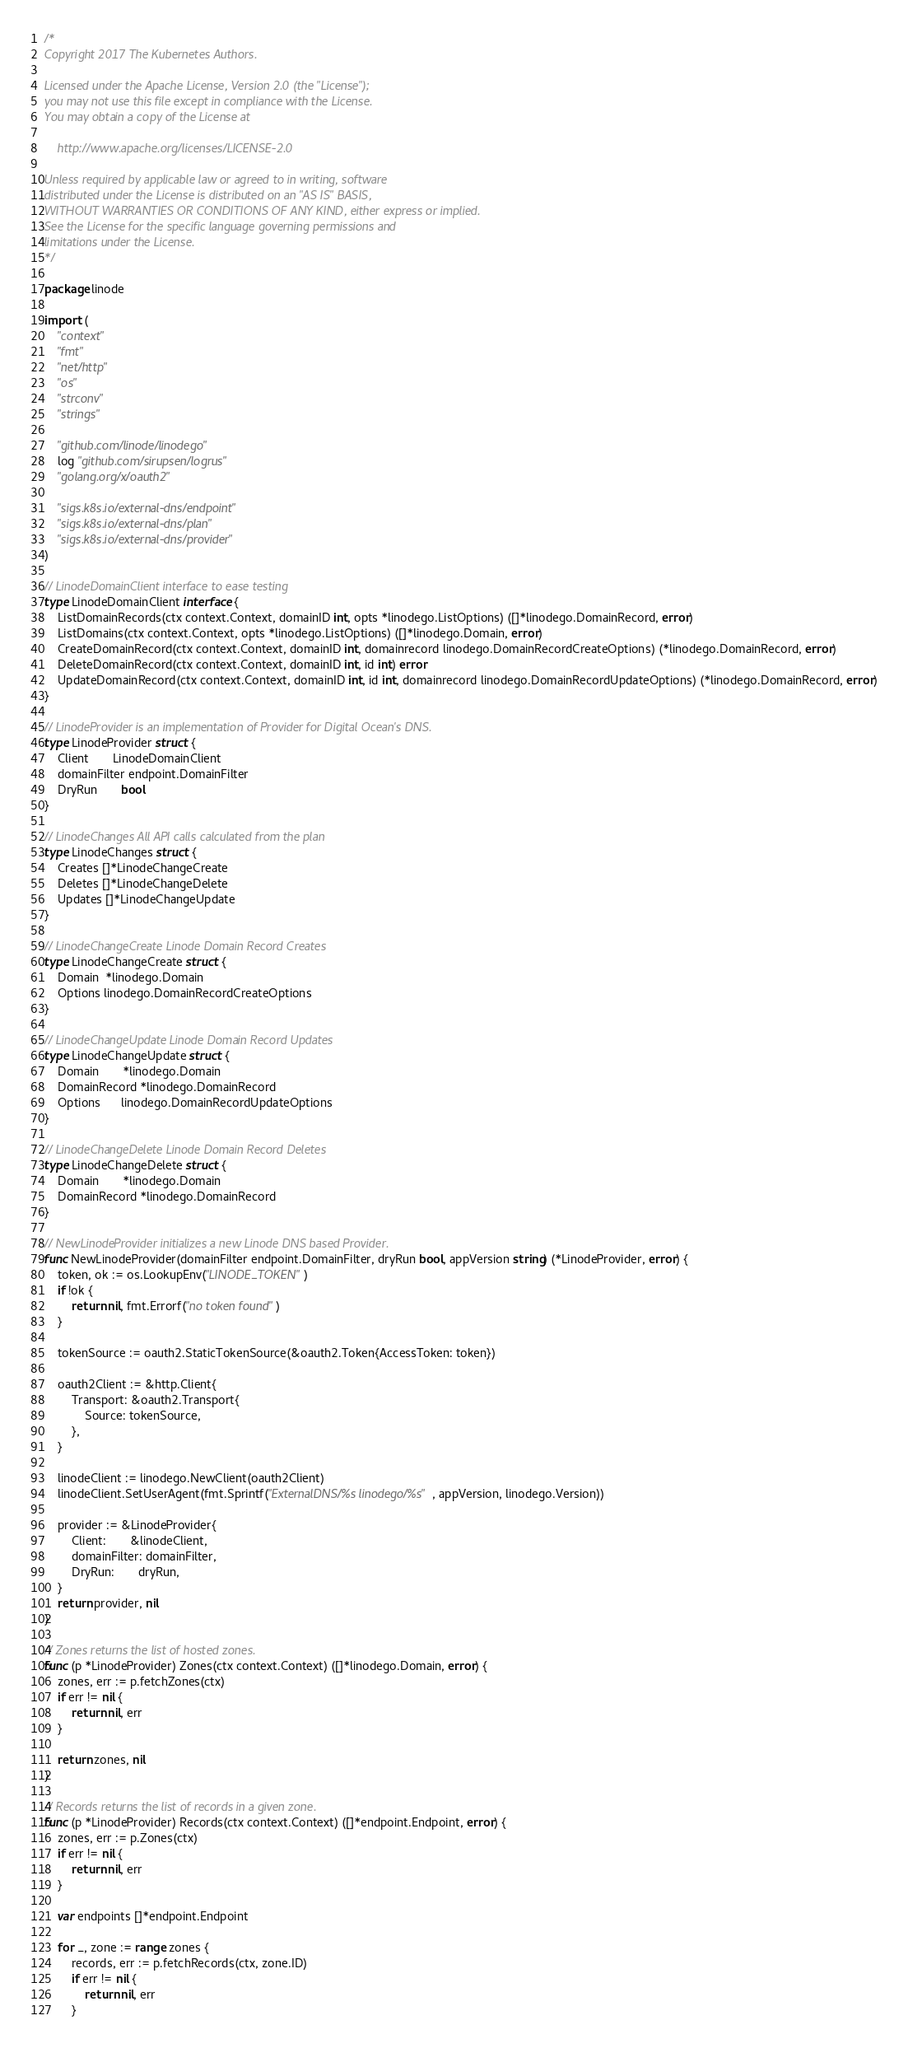Convert code to text. <code><loc_0><loc_0><loc_500><loc_500><_Go_>/*
Copyright 2017 The Kubernetes Authors.

Licensed under the Apache License, Version 2.0 (the "License");
you may not use this file except in compliance with the License.
You may obtain a copy of the License at

    http://www.apache.org/licenses/LICENSE-2.0

Unless required by applicable law or agreed to in writing, software
distributed under the License is distributed on an "AS IS" BASIS,
WITHOUT WARRANTIES OR CONDITIONS OF ANY KIND, either express or implied.
See the License for the specific language governing permissions and
limitations under the License.
*/

package linode

import (
	"context"
	"fmt"
	"net/http"
	"os"
	"strconv"
	"strings"

	"github.com/linode/linodego"
	log "github.com/sirupsen/logrus"
	"golang.org/x/oauth2"

	"sigs.k8s.io/external-dns/endpoint"
	"sigs.k8s.io/external-dns/plan"
	"sigs.k8s.io/external-dns/provider"
)

// LinodeDomainClient interface to ease testing
type LinodeDomainClient interface {
	ListDomainRecords(ctx context.Context, domainID int, opts *linodego.ListOptions) ([]*linodego.DomainRecord, error)
	ListDomains(ctx context.Context, opts *linodego.ListOptions) ([]*linodego.Domain, error)
	CreateDomainRecord(ctx context.Context, domainID int, domainrecord linodego.DomainRecordCreateOptions) (*linodego.DomainRecord, error)
	DeleteDomainRecord(ctx context.Context, domainID int, id int) error
	UpdateDomainRecord(ctx context.Context, domainID int, id int, domainrecord linodego.DomainRecordUpdateOptions) (*linodego.DomainRecord, error)
}

// LinodeProvider is an implementation of Provider for Digital Ocean's DNS.
type LinodeProvider struct {
	Client       LinodeDomainClient
	domainFilter endpoint.DomainFilter
	DryRun       bool
}

// LinodeChanges All API calls calculated from the plan
type LinodeChanges struct {
	Creates []*LinodeChangeCreate
	Deletes []*LinodeChangeDelete
	Updates []*LinodeChangeUpdate
}

// LinodeChangeCreate Linode Domain Record Creates
type LinodeChangeCreate struct {
	Domain  *linodego.Domain
	Options linodego.DomainRecordCreateOptions
}

// LinodeChangeUpdate Linode Domain Record Updates
type LinodeChangeUpdate struct {
	Domain       *linodego.Domain
	DomainRecord *linodego.DomainRecord
	Options      linodego.DomainRecordUpdateOptions
}

// LinodeChangeDelete Linode Domain Record Deletes
type LinodeChangeDelete struct {
	Domain       *linodego.Domain
	DomainRecord *linodego.DomainRecord
}

// NewLinodeProvider initializes a new Linode DNS based Provider.
func NewLinodeProvider(domainFilter endpoint.DomainFilter, dryRun bool, appVersion string) (*LinodeProvider, error) {
	token, ok := os.LookupEnv("LINODE_TOKEN")
	if !ok {
		return nil, fmt.Errorf("no token found")
	}

	tokenSource := oauth2.StaticTokenSource(&oauth2.Token{AccessToken: token})

	oauth2Client := &http.Client{
		Transport: &oauth2.Transport{
			Source: tokenSource,
		},
	}

	linodeClient := linodego.NewClient(oauth2Client)
	linodeClient.SetUserAgent(fmt.Sprintf("ExternalDNS/%s linodego/%s", appVersion, linodego.Version))

	provider := &LinodeProvider{
		Client:       &linodeClient,
		domainFilter: domainFilter,
		DryRun:       dryRun,
	}
	return provider, nil
}

// Zones returns the list of hosted zones.
func (p *LinodeProvider) Zones(ctx context.Context) ([]*linodego.Domain, error) {
	zones, err := p.fetchZones(ctx)
	if err != nil {
		return nil, err
	}

	return zones, nil
}

// Records returns the list of records in a given zone.
func (p *LinodeProvider) Records(ctx context.Context) ([]*endpoint.Endpoint, error) {
	zones, err := p.Zones(ctx)
	if err != nil {
		return nil, err
	}

	var endpoints []*endpoint.Endpoint

	for _, zone := range zones {
		records, err := p.fetchRecords(ctx, zone.ID)
		if err != nil {
			return nil, err
		}
</code> 